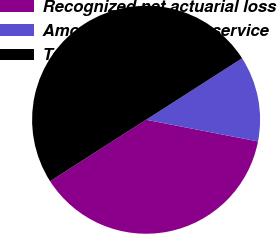Convert chart to OTSL. <chart><loc_0><loc_0><loc_500><loc_500><pie_chart><fcel>Recognized net actuarial loss<fcel>Amortization of prior service<fcel>Total<nl><fcel>37.89%<fcel>12.11%<fcel>50.0%<nl></chart> 